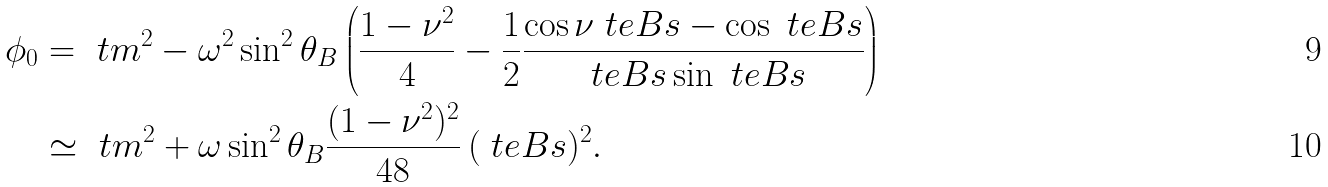<formula> <loc_0><loc_0><loc_500><loc_500>\phi _ { 0 } & = \ t m ^ { 2 } - \omega ^ { 2 } \sin ^ { 2 } \theta _ { B } \left ( \frac { 1 - \nu ^ { 2 } } { 4 } - \frac { 1 } { 2 } \frac { \cos \nu \ t e B s - \cos \ t e B s } { \ t e B s \sin \ t e B s } \right ) \\ & \simeq \ t m ^ { 2 } + \omega \sin ^ { 2 } \theta _ { B } \frac { ( 1 - \nu ^ { 2 } ) ^ { 2 } } { 4 8 } \, ( \ t e B s ) ^ { 2 } .</formula> 